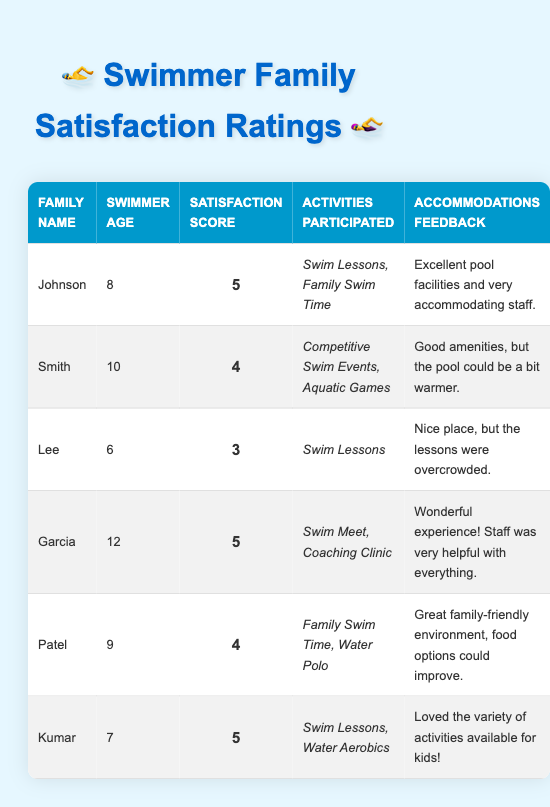What is the highest satisfaction score recorded in the table? The highest satisfaction score is found by reviewing the 'Satisfaction Score' column. The entries for Johnson, Garcia, and Kumar all have a score of 5, which is the maximum among all families.
Answer: 5 What activities did the Patel family participate in? To find the activities Patel participated in, I need to look at the row corresponding to Patel and check the 'Activities Participated' column, which lists 'Family Swim Time' and 'Water Polo'.
Answer: Family Swim Time, Water Polo How many families reported a satisfaction score of 4 or higher? I need to count how many rows have a 'Satisfaction Score' of 4 or higher. The families with scores of 4 or 5 are Johnson, Smith, Garcia, Patel, and Kumar, totaling 5 families.
Answer: 5 What is the average swimmer age among families with a satisfaction score of 5? First, identify the families with a score of 5, which are Johnson, Garcia, and Kumar. Their ages are 8, 12, and 7. Then calculate the average: (8 + 12 + 7) / 3 = 27 / 3 = 9 years.
Answer: 9 Did any family provide feedback indicating that the pool temperature could improve? The feedback of the Smith family mentions that "the pool could be a bit warmer," indicating that some improvement is needed regarding the pool temperature.
Answer: Yes Which family had the lowest satisfaction score and what was their feedback? The lowest satisfaction score is 3, attributed to the Lee family. The feedback indicates that the 'lessons were overcrowded,' reflecting their dissatisfaction.
Answer: Lee, feedback: lessons were overcrowded What percentage of families participated in 'Swim Lessons'? The families participating in 'Swim Lessons' are Johnson, Lee, and Kumar. Out of 6 families, 3 participated in 'Swim Lessons'. To find the percentage, compute (3/6) * 100 = 50%.
Answer: 50% How many families provided feedback about food options? By examining the feedback column, I can see that only Patel specifically mentions food options that could improve. Therefore, only Patel provided such feedback.
Answer: 1 If a family is looking for activities that include water polo, which family should they refer to? The Patel family is the only family that listed 'Water Polo' under 'Activities Participated', so they should refer to the Patel family for this activity.
Answer: Patel 